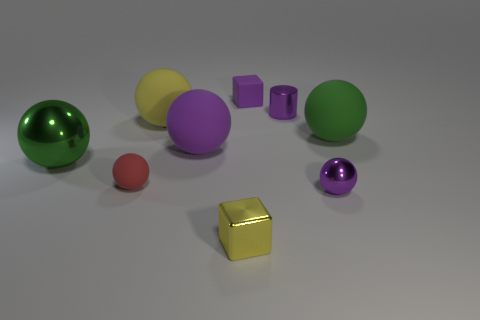There is a matte thing that is on the left side of the yellow matte ball; does it have the same color as the cube to the right of the tiny yellow block?
Your answer should be compact. No. Is there any other thing of the same color as the small cylinder?
Make the answer very short. Yes. What is the color of the small sphere right of the tiny cube behind the yellow matte object?
Keep it short and to the point. Purple. Are there any tiny matte balls?
Ensure brevity in your answer.  Yes. The big rubber sphere that is both left of the tiny cylinder and to the right of the yellow sphere is what color?
Make the answer very short. Purple. Does the purple rubber object that is in front of the big green matte ball have the same size as the yellow thing in front of the green metallic ball?
Make the answer very short. No. How many other objects are there of the same size as the red sphere?
Make the answer very short. 4. There is a large green matte thing that is behind the large green metallic object; how many purple matte balls are behind it?
Your answer should be compact. 0. Are there fewer shiny cylinders in front of the small metallic cube than purple blocks?
Provide a short and direct response. Yes. What shape is the small purple object that is behind the small purple metallic thing that is behind the green object right of the tiny purple rubber thing?
Offer a very short reply. Cube. 